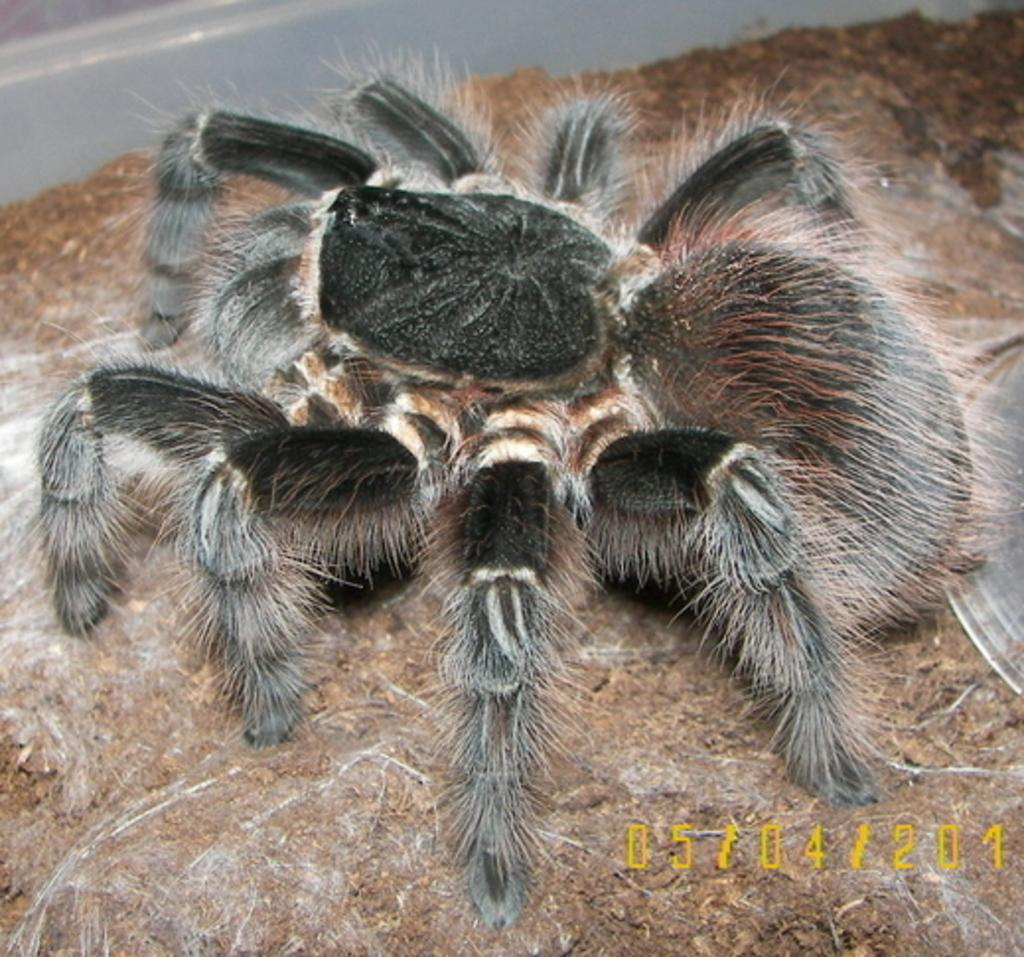What type of creature can be seen in the image? There is an insect in the image. What is the insect resting on? The insect is on a brown-colored surface. What does the brown-colored surface resemble? The brown-colored surface resembles soil. Can you tell me how many bubbles are surrounding the insect in the image? There are no bubbles present in the image; the insect is resting on a brown-colored surface that resembles soil. 